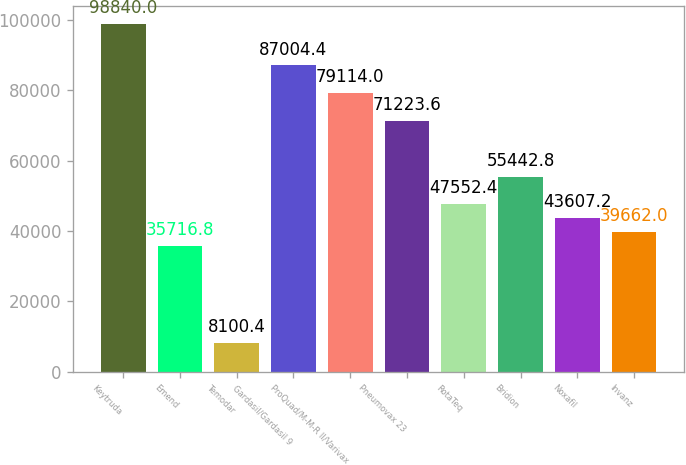<chart> <loc_0><loc_0><loc_500><loc_500><bar_chart><fcel>Keytruda<fcel>Emend<fcel>Temodar<fcel>Gardasil/Gardasil 9<fcel>ProQuad/M-M-R II/Varivax<fcel>Pneumovax 23<fcel>RotaTeq<fcel>Bridion<fcel>Noxafil<fcel>Invanz<nl><fcel>98840<fcel>35716.8<fcel>8100.4<fcel>87004.4<fcel>79114<fcel>71223.6<fcel>47552.4<fcel>55442.8<fcel>43607.2<fcel>39662<nl></chart> 